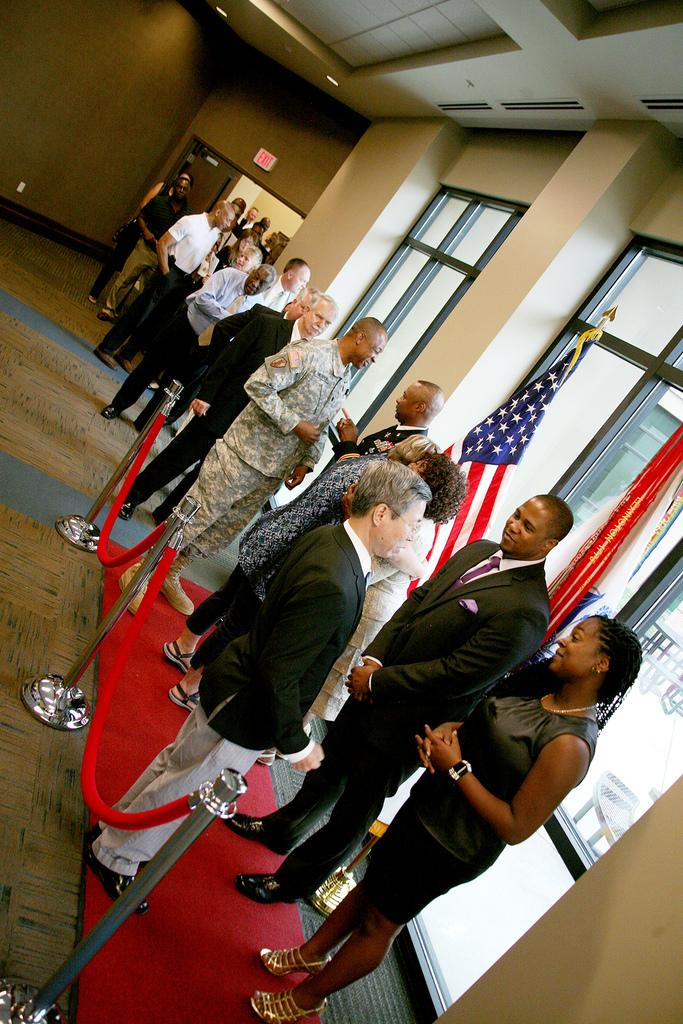Who is present in the image? There are people in the image. How are the people arranged in the image? The people are in a line. What are the people doing in the image? The people are meeting delegates. Where is the meeting taking place? The meeting is taking place inside a room. How many pigs are present in the image? There are no pigs present in the image; it features people meeting delegates inside a room. What type of frog can be seen interacting with the delegates in the image? There is no frog present in the image; it features people meeting delegates inside a room. 